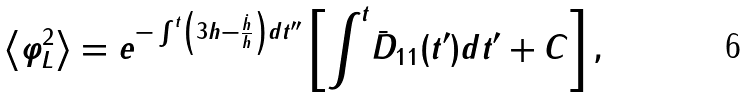<formula> <loc_0><loc_0><loc_500><loc_500>\left < \varphi ^ { 2 } _ { L } \right > = e ^ { - \int ^ { t } \left ( 3 h - \frac { \dot { h } } { h } \right ) d t ^ { \prime \prime } } \left [ { \int } ^ { t } \bar { D } _ { 1 1 } ( t ^ { \prime } ) d t ^ { \prime } + C \right ] ,</formula> 